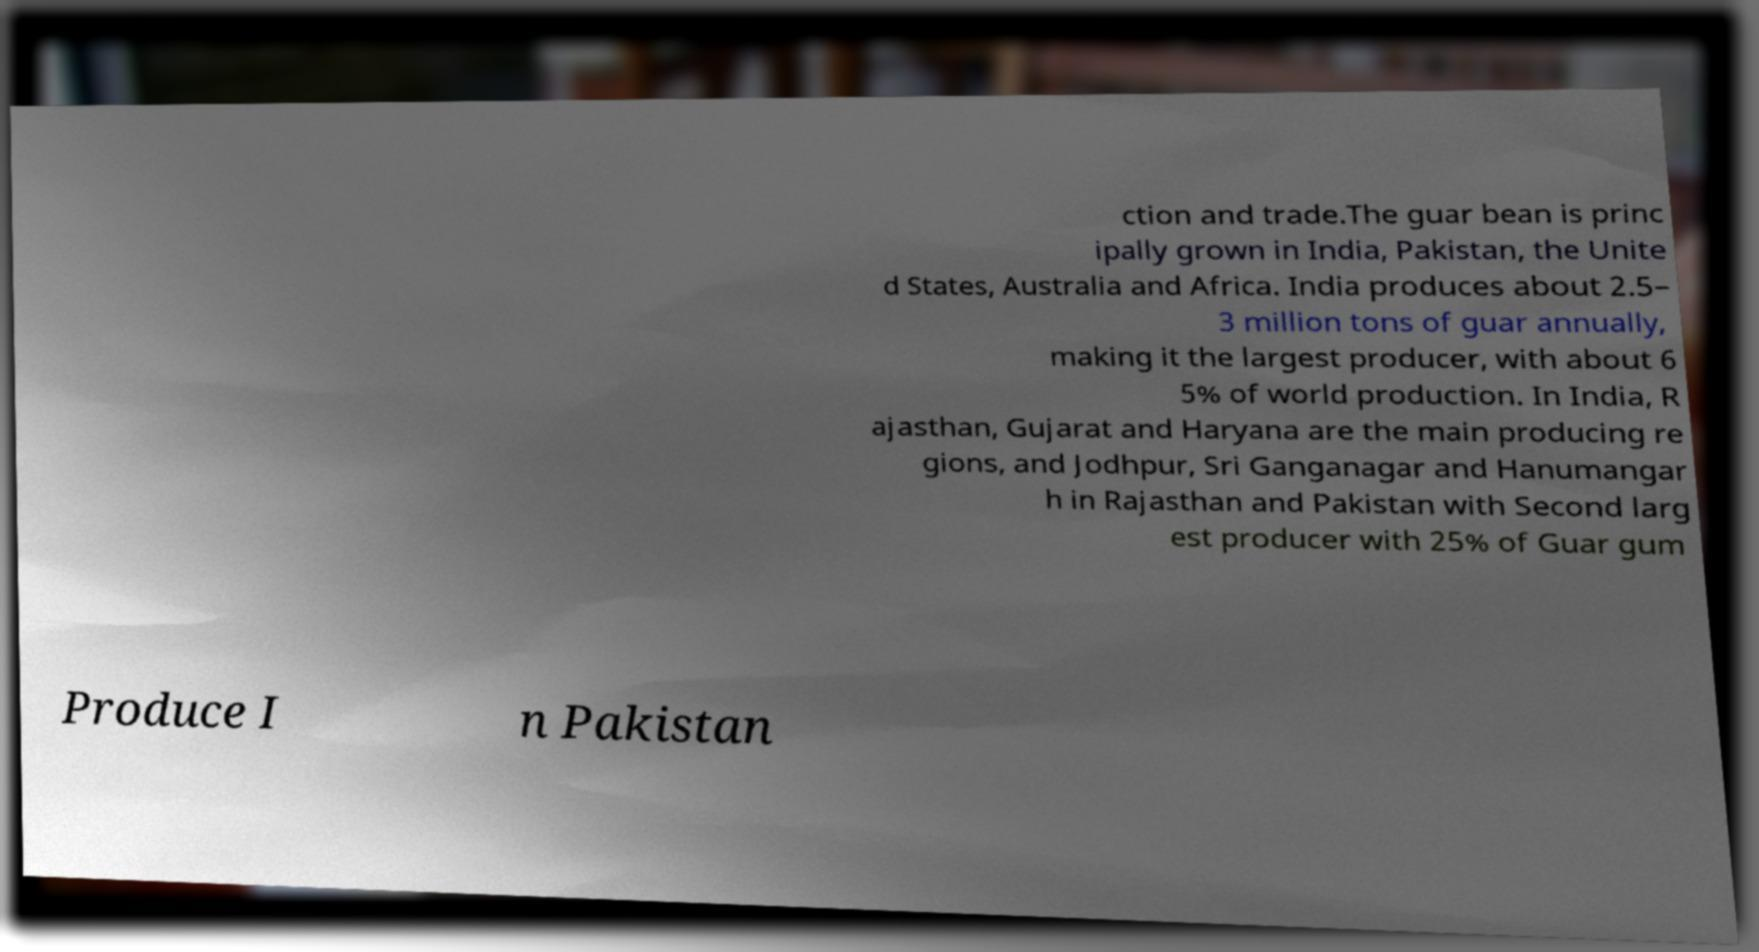Could you extract and type out the text from this image? ction and trade.The guar bean is princ ipally grown in India, Pakistan, the Unite d States, Australia and Africa. India produces about 2.5– 3 million tons of guar annually, making it the largest producer, with about 6 5% of world production. In India, R ajasthan, Gujarat and Haryana are the main producing re gions, and Jodhpur, Sri Ganganagar and Hanumangar h in Rajasthan and Pakistan with Second larg est producer with 25% of Guar gum Produce I n Pakistan 